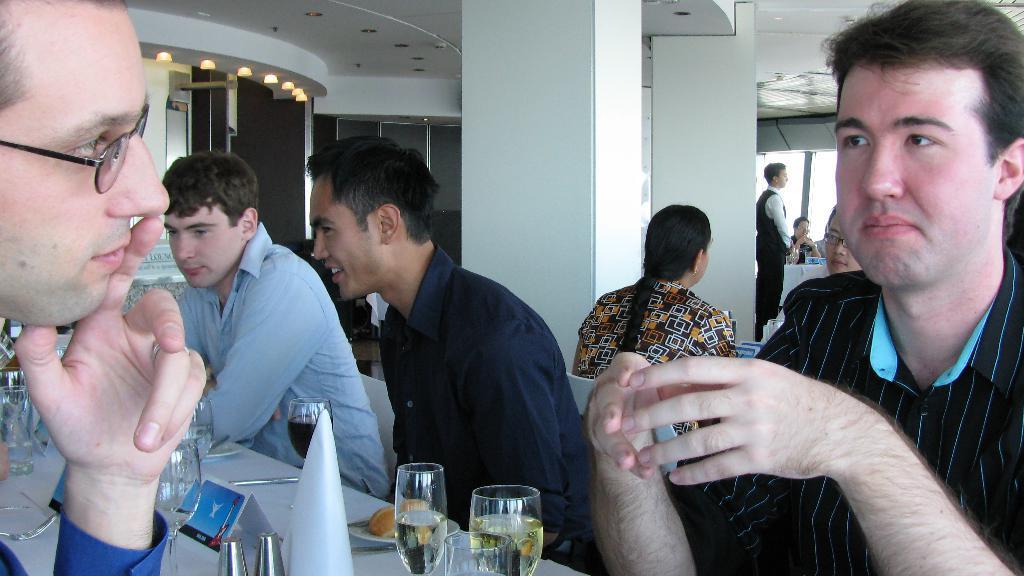In one or two sentences, can you explain what this image depicts? This is an inside view of a room. Here I can see few men sitting around a table. On the table, I can see few glasses, plates, food items, papers, spoons and some other objects. In the background, I can see some other people and also there are two pillars. On the left side there is a glass and there are few lights at the top. In the background there is a window. 